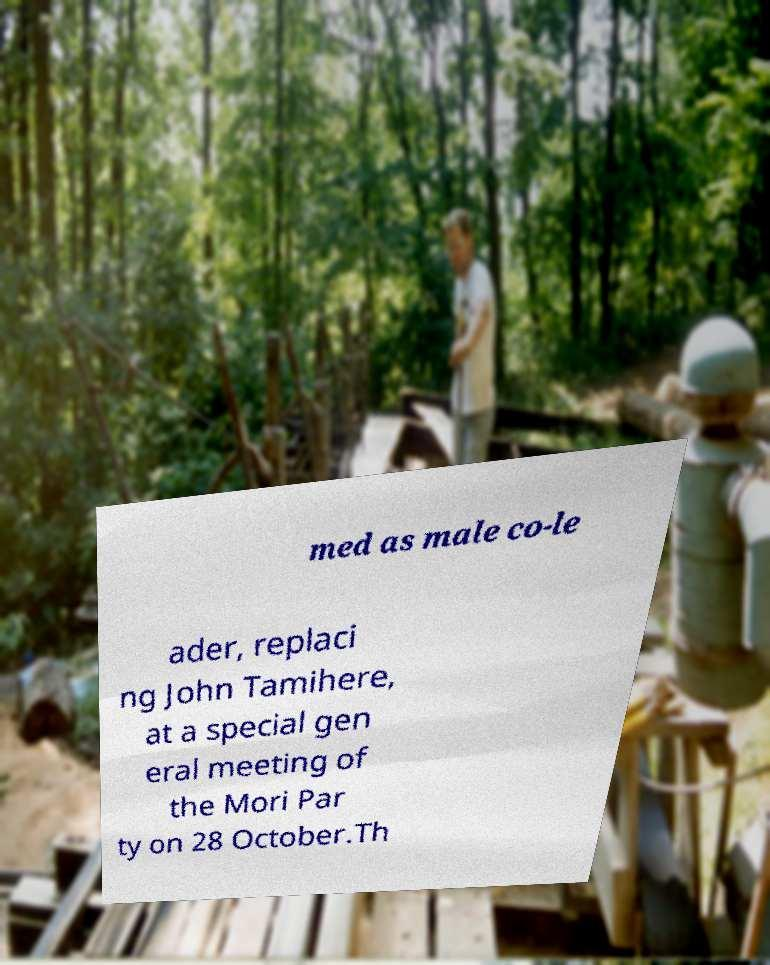Could you extract and type out the text from this image? med as male co-le ader, replaci ng John Tamihere, at a special gen eral meeting of the Mori Par ty on 28 October.Th 